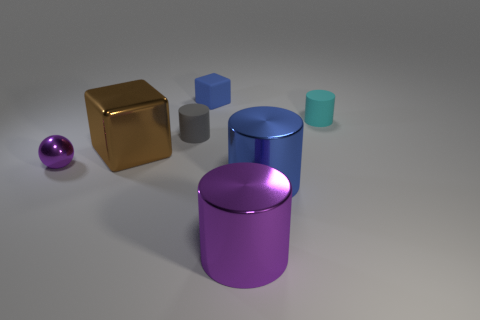There is another thing that is the same shape as the small blue matte object; what color is it?
Your answer should be compact. Brown. There is another matte thing that is the same shape as the small cyan matte thing; what is its size?
Provide a short and direct response. Small. What is the material of the tiny thing that is both on the left side of the purple cylinder and right of the gray object?
Your response must be concise. Rubber. There is a tiny cylinder that is in front of the cyan object; does it have the same color as the metal sphere?
Provide a short and direct response. No. Do the metal sphere and the cube that is behind the large brown block have the same color?
Keep it short and to the point. No. There is a blue metal object; are there any big blue cylinders on the left side of it?
Offer a terse response. No. Is the material of the small sphere the same as the blue cylinder?
Give a very brief answer. Yes. What material is the blue thing that is the same size as the brown metal block?
Your answer should be very brief. Metal. What number of things are either cubes to the left of the gray rubber object or brown matte objects?
Your answer should be very brief. 1. Is the number of big brown objects behind the brown metal block the same as the number of gray rubber objects?
Offer a very short reply. No. 